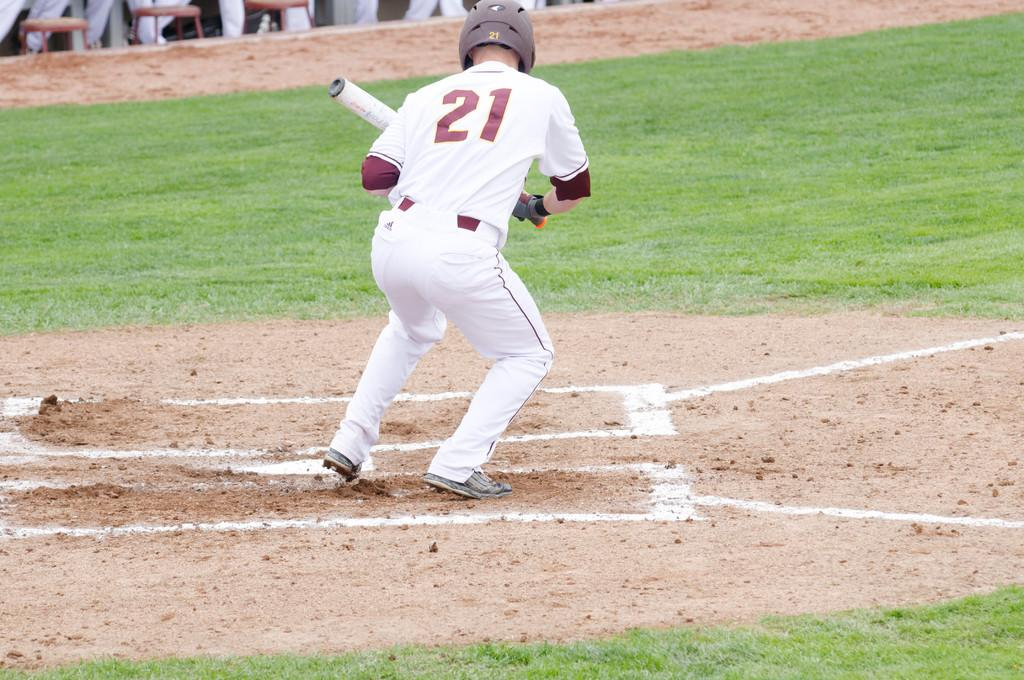Provide a one-sentence caption for the provided image. A batter numbered 21 is ready to bunt and head for the first base. 